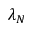<formula> <loc_0><loc_0><loc_500><loc_500>\lambda _ { N }</formula> 